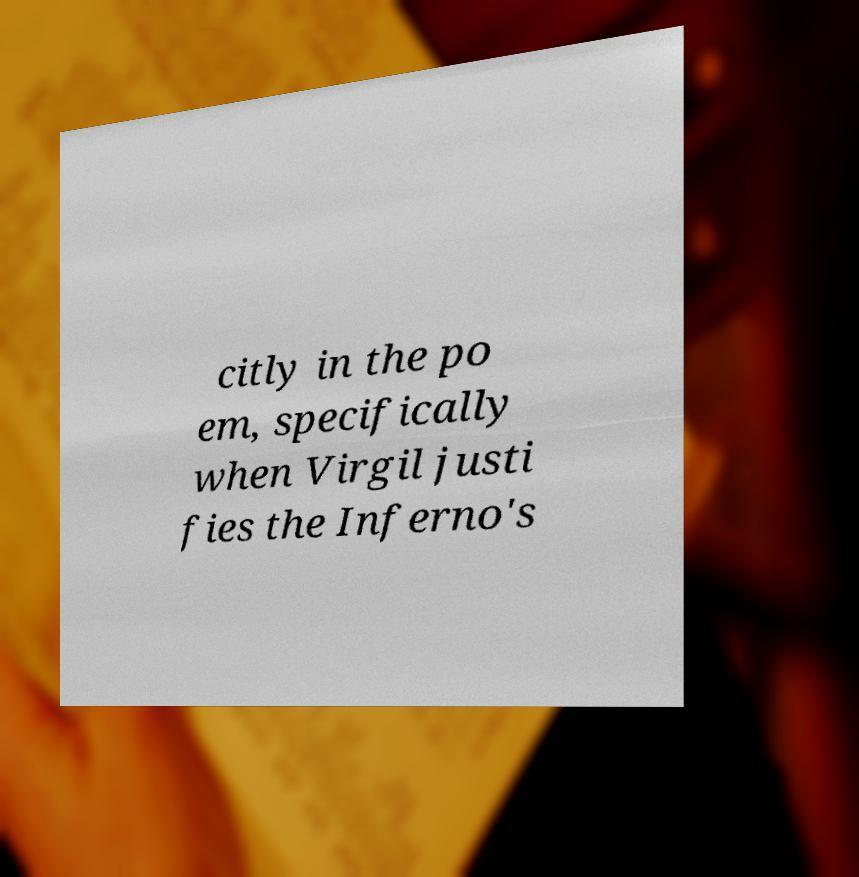Please identify and transcribe the text found in this image. citly in the po em, specifically when Virgil justi fies the Inferno's 